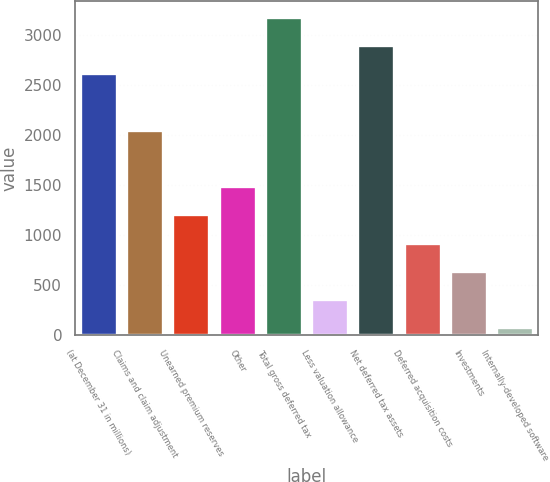Convert chart. <chart><loc_0><loc_0><loc_500><loc_500><bar_chart><fcel>(at December 31 in millions)<fcel>Claims and claim adjustment<fcel>Unearned premium reserves<fcel>Other<fcel>Total gross deferred tax<fcel>Less valuation allowance<fcel>Net deferred tax assets<fcel>Deferred acquisition costs<fcel>Investments<fcel>Internally-developed software<nl><fcel>2617.8<fcel>2053.4<fcel>1206.8<fcel>1489<fcel>3182.2<fcel>360.2<fcel>2900<fcel>924.6<fcel>642.4<fcel>78<nl></chart> 